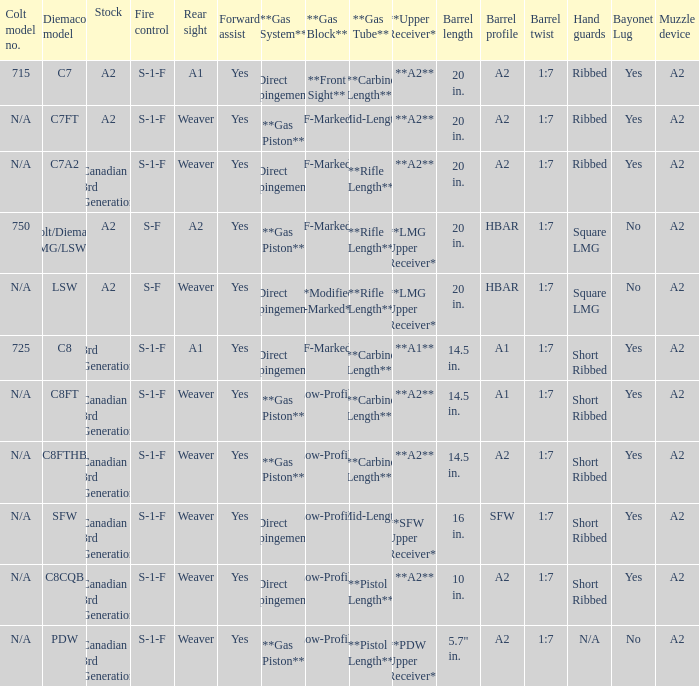Which Hand guards has a Barrel profile of a2 and a Rear sight of weaver? Ribbed, Ribbed, Short Ribbed, Short Ribbed, N/A. 